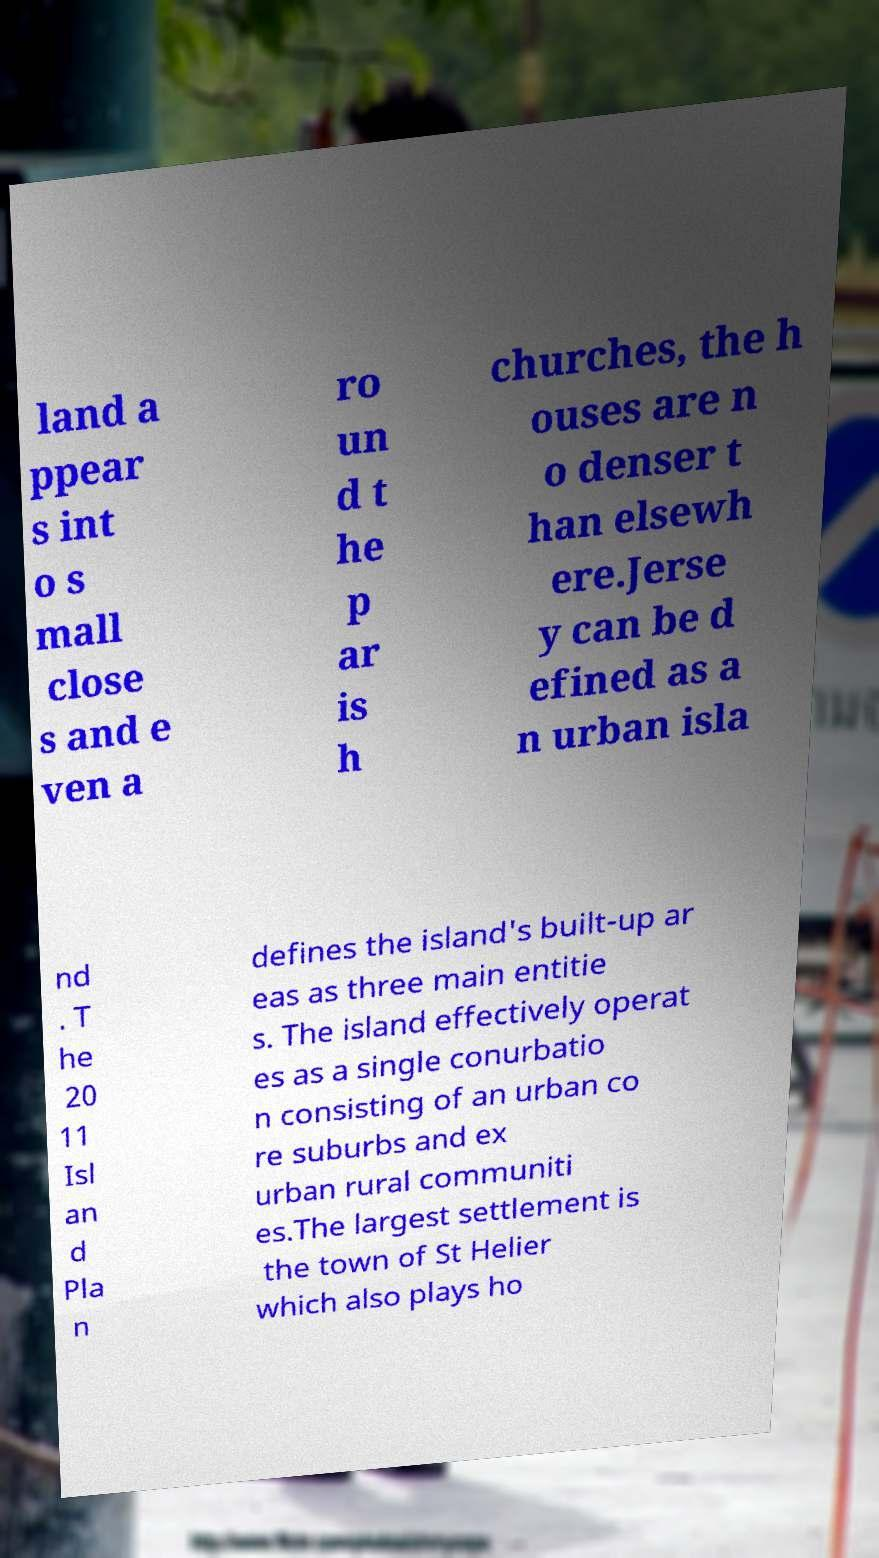For documentation purposes, I need the text within this image transcribed. Could you provide that? land a ppear s int o s mall close s and e ven a ro un d t he p ar is h churches, the h ouses are n o denser t han elsewh ere.Jerse y can be d efined as a n urban isla nd . T he 20 11 Isl an d Pla n defines the island's built-up ar eas as three main entitie s. The island effectively operat es as a single conurbatio n consisting of an urban co re suburbs and ex urban rural communiti es.The largest settlement is the town of St Helier which also plays ho 